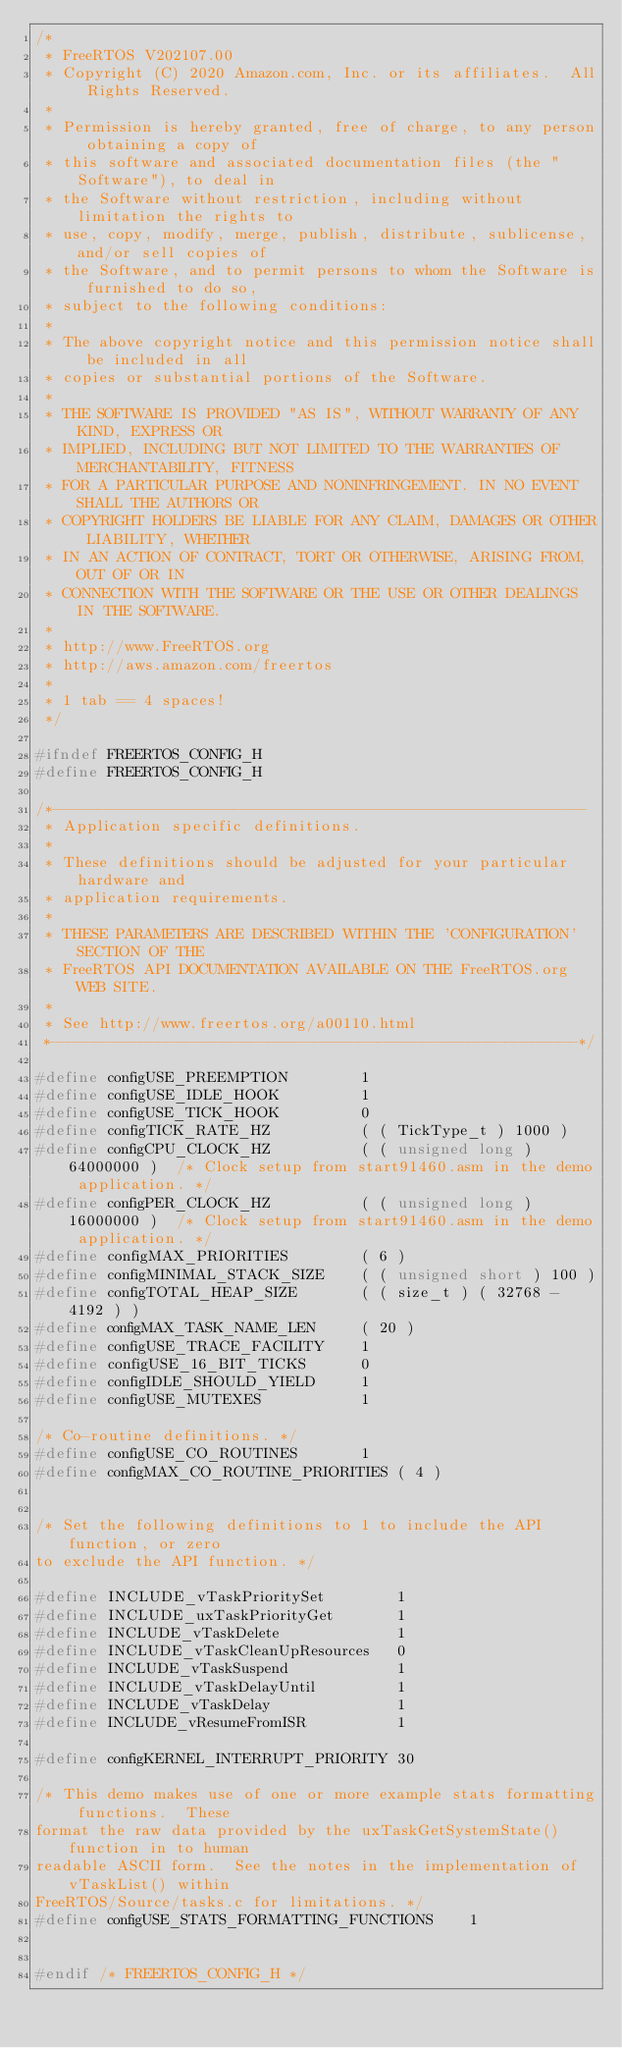<code> <loc_0><loc_0><loc_500><loc_500><_C_>/*
 * FreeRTOS V202107.00
 * Copyright (C) 2020 Amazon.com, Inc. or its affiliates.  All Rights Reserved.
 *
 * Permission is hereby granted, free of charge, to any person obtaining a copy of
 * this software and associated documentation files (the "Software"), to deal in
 * the Software without restriction, including without limitation the rights to
 * use, copy, modify, merge, publish, distribute, sublicense, and/or sell copies of
 * the Software, and to permit persons to whom the Software is furnished to do so,
 * subject to the following conditions:
 *
 * The above copyright notice and this permission notice shall be included in all
 * copies or substantial portions of the Software.
 *
 * THE SOFTWARE IS PROVIDED "AS IS", WITHOUT WARRANTY OF ANY KIND, EXPRESS OR
 * IMPLIED, INCLUDING BUT NOT LIMITED TO THE WARRANTIES OF MERCHANTABILITY, FITNESS
 * FOR A PARTICULAR PURPOSE AND NONINFRINGEMENT. IN NO EVENT SHALL THE AUTHORS OR
 * COPYRIGHT HOLDERS BE LIABLE FOR ANY CLAIM, DAMAGES OR OTHER LIABILITY, WHETHER
 * IN AN ACTION OF CONTRACT, TORT OR OTHERWISE, ARISING FROM, OUT OF OR IN
 * CONNECTION WITH THE SOFTWARE OR THE USE OR OTHER DEALINGS IN THE SOFTWARE.
 *
 * http://www.FreeRTOS.org
 * http://aws.amazon.com/freertos
 *
 * 1 tab == 4 spaces!
 */

#ifndef FREERTOS_CONFIG_H
#define FREERTOS_CONFIG_H

/*-----------------------------------------------------------
 * Application specific definitions.
 *
 * These definitions should be adjusted for your particular hardware and
 * application requirements.
 *
 * THESE PARAMETERS ARE DESCRIBED WITHIN THE 'CONFIGURATION' SECTION OF THE
 * FreeRTOS API DOCUMENTATION AVAILABLE ON THE FreeRTOS.org WEB SITE. 
 *
 * See http://www.freertos.org/a00110.html
 *----------------------------------------------------------*/

#define configUSE_PREEMPTION		1
#define configUSE_IDLE_HOOK			1
#define configUSE_TICK_HOOK			0
#define configTICK_RATE_HZ			( ( TickType_t ) 1000 )
#define configCPU_CLOCK_HZ			( ( unsigned long ) 64000000 )  /* Clock setup from start91460.asm in the demo application. */
#define configPER_CLOCK_HZ			( ( unsigned long ) 16000000 )  /* Clock setup from start91460.asm in the demo application. */
#define configMAX_PRIORITIES		( 6 )
#define configMINIMAL_STACK_SIZE	( ( unsigned short ) 100 )
#define configTOTAL_HEAP_SIZE		( ( size_t ) ( 32768 - 4192 ) )
#define configMAX_TASK_NAME_LEN		( 20 )
#define configUSE_TRACE_FACILITY	1
#define configUSE_16_BIT_TICKS		0
#define configIDLE_SHOULD_YIELD		1
#define configUSE_MUTEXES           1

/* Co-routine definitions. */
#define configUSE_CO_ROUTINES 		1
#define configMAX_CO_ROUTINE_PRIORITIES ( 4 )


/* Set the following definitions to 1 to include the API function, or zero
to exclude the API function. */

#define INCLUDE_vTaskPrioritySet		1
#define INCLUDE_uxTaskPriorityGet		1
#define INCLUDE_vTaskDelete				1
#define INCLUDE_vTaskCleanUpResources	0
#define INCLUDE_vTaskSuspend			1
#define INCLUDE_vTaskDelayUntil			1
#define INCLUDE_vTaskDelay				1
#define INCLUDE_vResumeFromISR          1

#define configKERNEL_INTERRUPT_PRIORITY 30

/* This demo makes use of one or more example stats formatting functions.  These
format the raw data provided by the uxTaskGetSystemState() function in to human
readable ASCII form.  See the notes in the implementation of vTaskList() within 
FreeRTOS/Source/tasks.c for limitations. */
#define configUSE_STATS_FORMATTING_FUNCTIONS	1


#endif /* FREERTOS_CONFIG_H */
</code> 